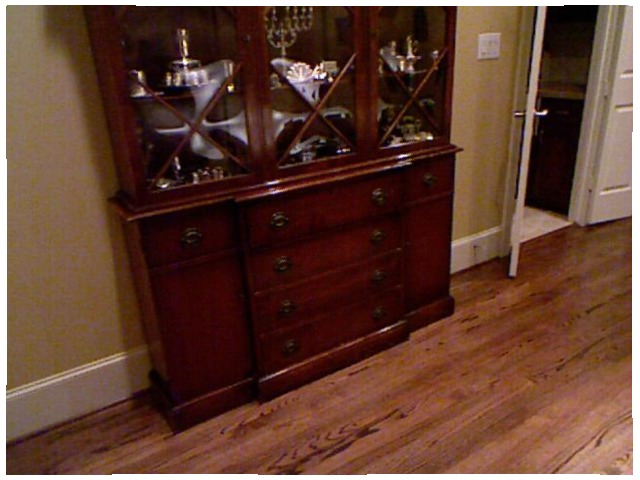<image>
Can you confirm if the hutch is behind the floor? No. The hutch is not behind the floor. From this viewpoint, the hutch appears to be positioned elsewhere in the scene. Is the china in the cabinet? Yes. The china is contained within or inside the cabinet, showing a containment relationship. 